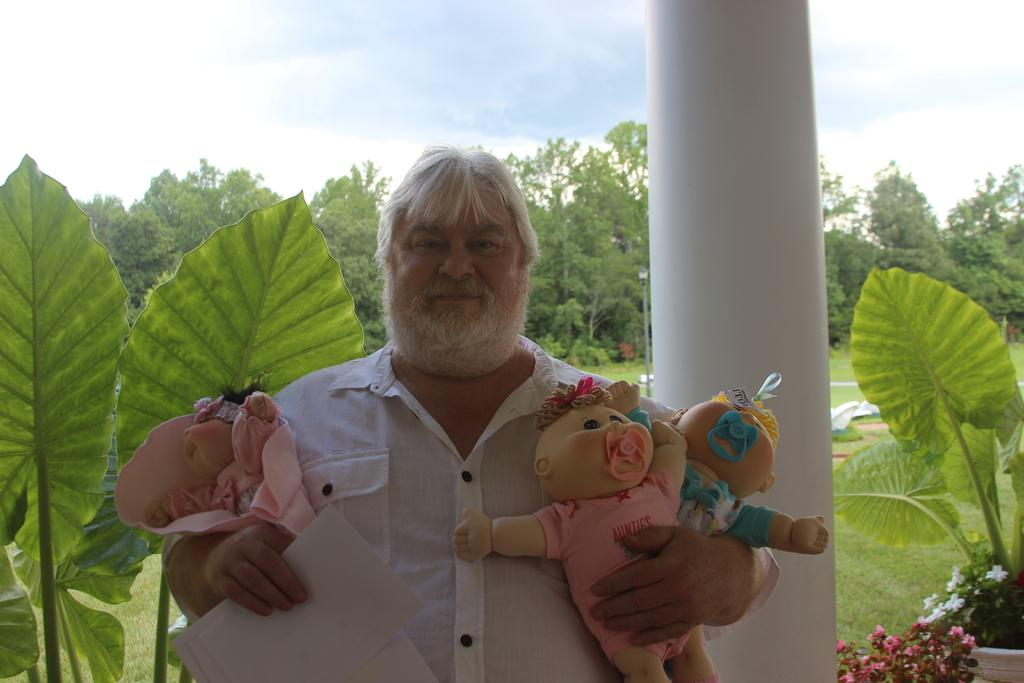What is the man in the image wearing? The man is wearing a white shirt. What is the man holding in the image? The man is holding papers and toys. What type of vegetation can be seen in the image? There are flowers, plants, trees, and grass visible in the image. What part of the natural environment is visible in the image? The sky is visible in the image. What type of wheel can be seen in the image? There is no wheel present in the image. What test is the man taking in the image? There is no test being taken in the image; the man is holding papers and toys. 